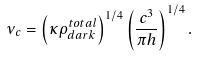<formula> <loc_0><loc_0><loc_500><loc_500>\nu _ { c } = \left ( \kappa \rho _ { d a r k } ^ { t o t a l } \right ) ^ { 1 / 4 } \left ( \frac { c ^ { 3 } } { \pi h } \right ) ^ { 1 / 4 } .</formula> 